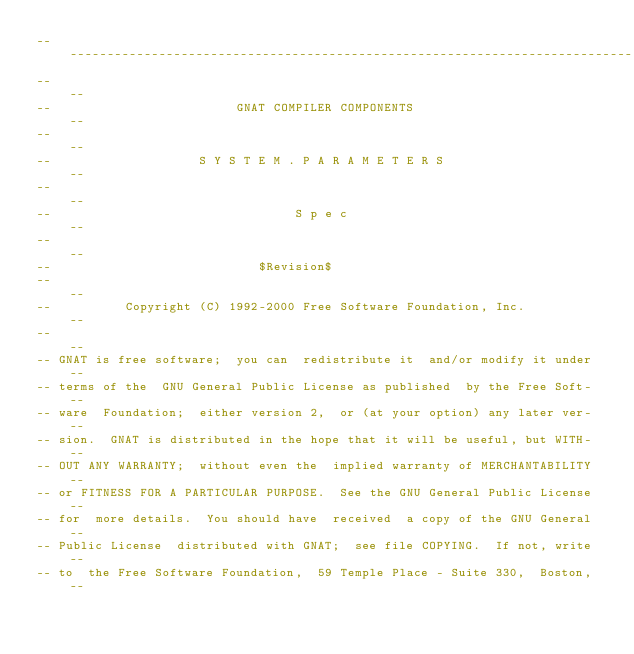<code> <loc_0><loc_0><loc_500><loc_500><_Ada_>------------------------------------------------------------------------------
--                                                                          --
--                         GNAT COMPILER COMPONENTS                         --
--                                                                          --
--                    S Y S T E M . P A R A M E T E R S                     --
--                                                                          --
--                                 S p e c                                  --
--                                                                          --
--                            $Revision$
--                                                                          --
--          Copyright (C) 1992-2000 Free Software Foundation, Inc.          --
--                                                                          --
-- GNAT is free software;  you can  redistribute it  and/or modify it under --
-- terms of the  GNU General Public License as published  by the Free Soft- --
-- ware  Foundation;  either version 2,  or (at your option) any later ver- --
-- sion.  GNAT is distributed in the hope that it will be useful, but WITH- --
-- OUT ANY WARRANTY;  without even the  implied warranty of MERCHANTABILITY --
-- or FITNESS FOR A PARTICULAR PURPOSE.  See the GNU General Public License --
-- for  more details.  You should have  received  a copy of the GNU General --
-- Public License  distributed with GNAT;  see file COPYING.  If not, write --
-- to  the Free Software Foundation,  59 Temple Place - Suite 330,  Boston, --</code> 